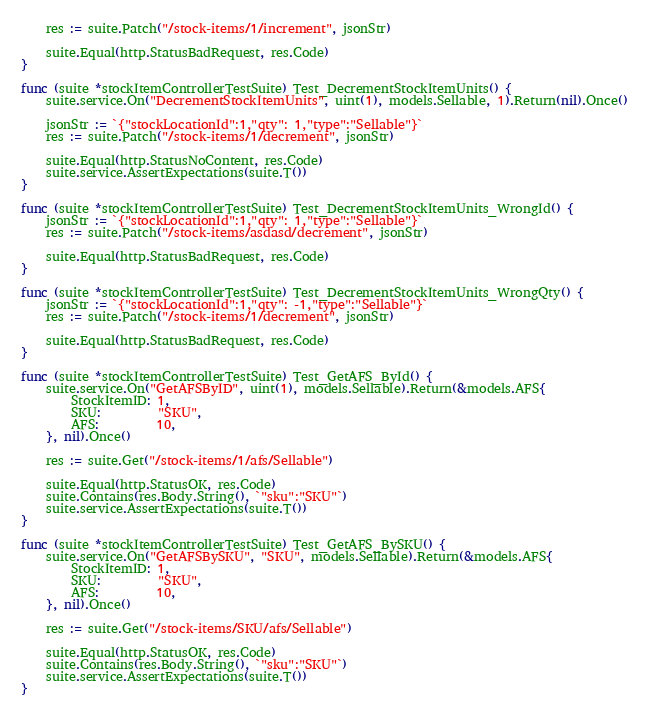<code> <loc_0><loc_0><loc_500><loc_500><_Go_>	res := suite.Patch("/stock-items/1/increment", jsonStr)

	suite.Equal(http.StatusBadRequest, res.Code)
}

func (suite *stockItemControllerTestSuite) Test_DecrementStockItemUnits() {
	suite.service.On("DecrementStockItemUnits", uint(1), models.Sellable, 1).Return(nil).Once()

	jsonStr := `{"stockLocationId":1,"qty": 1,"type":"Sellable"}`
	res := suite.Patch("/stock-items/1/decrement", jsonStr)

	suite.Equal(http.StatusNoContent, res.Code)
	suite.service.AssertExpectations(suite.T())
}

func (suite *stockItemControllerTestSuite) Test_DecrementStockItemUnits_WrongId() {
	jsonStr := `{"stockLocationId":1,"qty": 1,"type":"Sellable"}`
	res := suite.Patch("/stock-items/asdasd/decrement", jsonStr)

	suite.Equal(http.StatusBadRequest, res.Code)
}

func (suite *stockItemControllerTestSuite) Test_DecrementStockItemUnits_WrongQty() {
	jsonStr := `{"stockLocationId":1,"qty": -1,"type":"Sellable"}`
	res := suite.Patch("/stock-items/1/decrement", jsonStr)

	suite.Equal(http.StatusBadRequest, res.Code)
}

func (suite *stockItemControllerTestSuite) Test_GetAFS_ById() {
	suite.service.On("GetAFSByID", uint(1), models.Sellable).Return(&models.AFS{
		StockItemID: 1,
		SKU:         "SKU",
		AFS:         10,
	}, nil).Once()

	res := suite.Get("/stock-items/1/afs/Sellable")

	suite.Equal(http.StatusOK, res.Code)
	suite.Contains(res.Body.String(), `"sku":"SKU"`)
	suite.service.AssertExpectations(suite.T())
}

func (suite *stockItemControllerTestSuite) Test_GetAFS_BySKU() {
	suite.service.On("GetAFSBySKU", "SKU", models.Sellable).Return(&models.AFS{
		StockItemID: 1,
		SKU:         "SKU",
		AFS:         10,
	}, nil).Once()

	res := suite.Get("/stock-items/SKU/afs/Sellable")

	suite.Equal(http.StatusOK, res.Code)
	suite.Contains(res.Body.String(), `"sku":"SKU"`)
	suite.service.AssertExpectations(suite.T())
}
</code> 